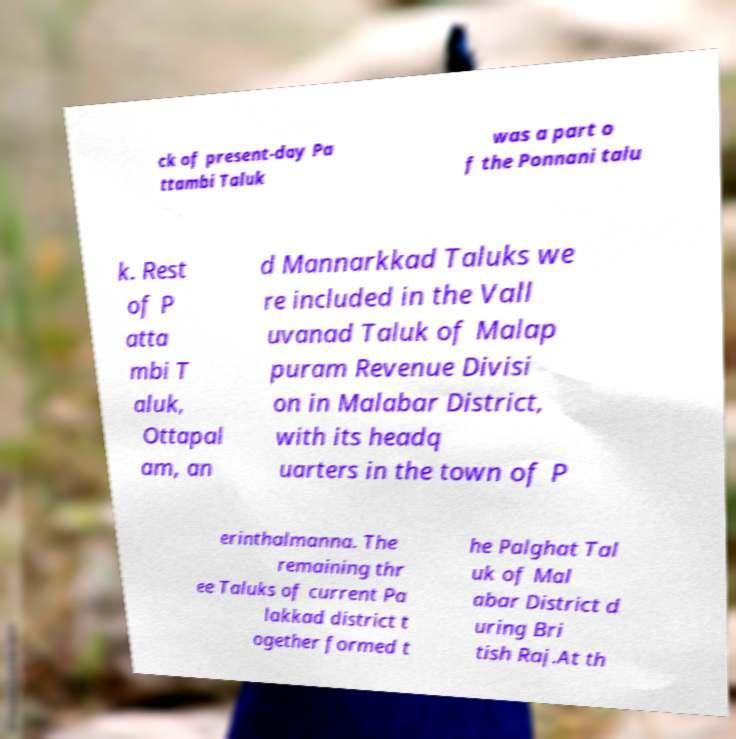There's text embedded in this image that I need extracted. Can you transcribe it verbatim? ck of present-day Pa ttambi Taluk was a part o f the Ponnani talu k. Rest of P atta mbi T aluk, Ottapal am, an d Mannarkkad Taluks we re included in the Vall uvanad Taluk of Malap puram Revenue Divisi on in Malabar District, with its headq uarters in the town of P erinthalmanna. The remaining thr ee Taluks of current Pa lakkad district t ogether formed t he Palghat Tal uk of Mal abar District d uring Bri tish Raj.At th 